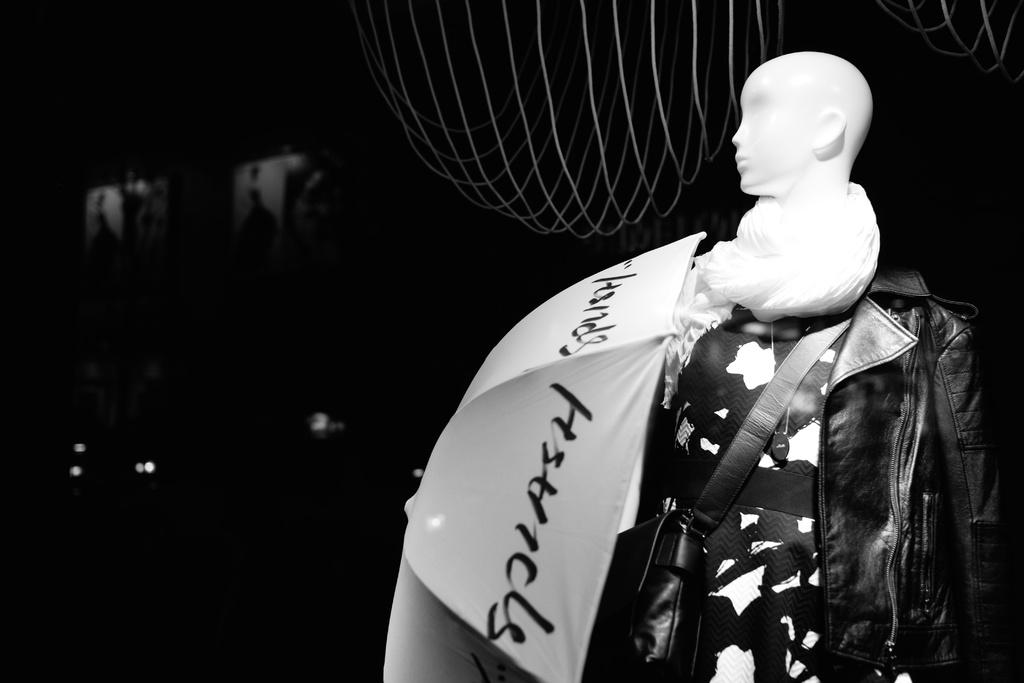What is the main subject in the image? There is a statue in the image. What other items can be seen in the image? There is a bag, a jacket, and an umbrella in the image. How would you describe the background of the image? The background of the image is dark. How many cents are visible on the statue in the image? There are no cents visible on the statue in the image. Is there a volleyball game taking place in the background of the image? There is no volleyball game or any reference to a recess in the image; it primarily features a statue and other objects. 